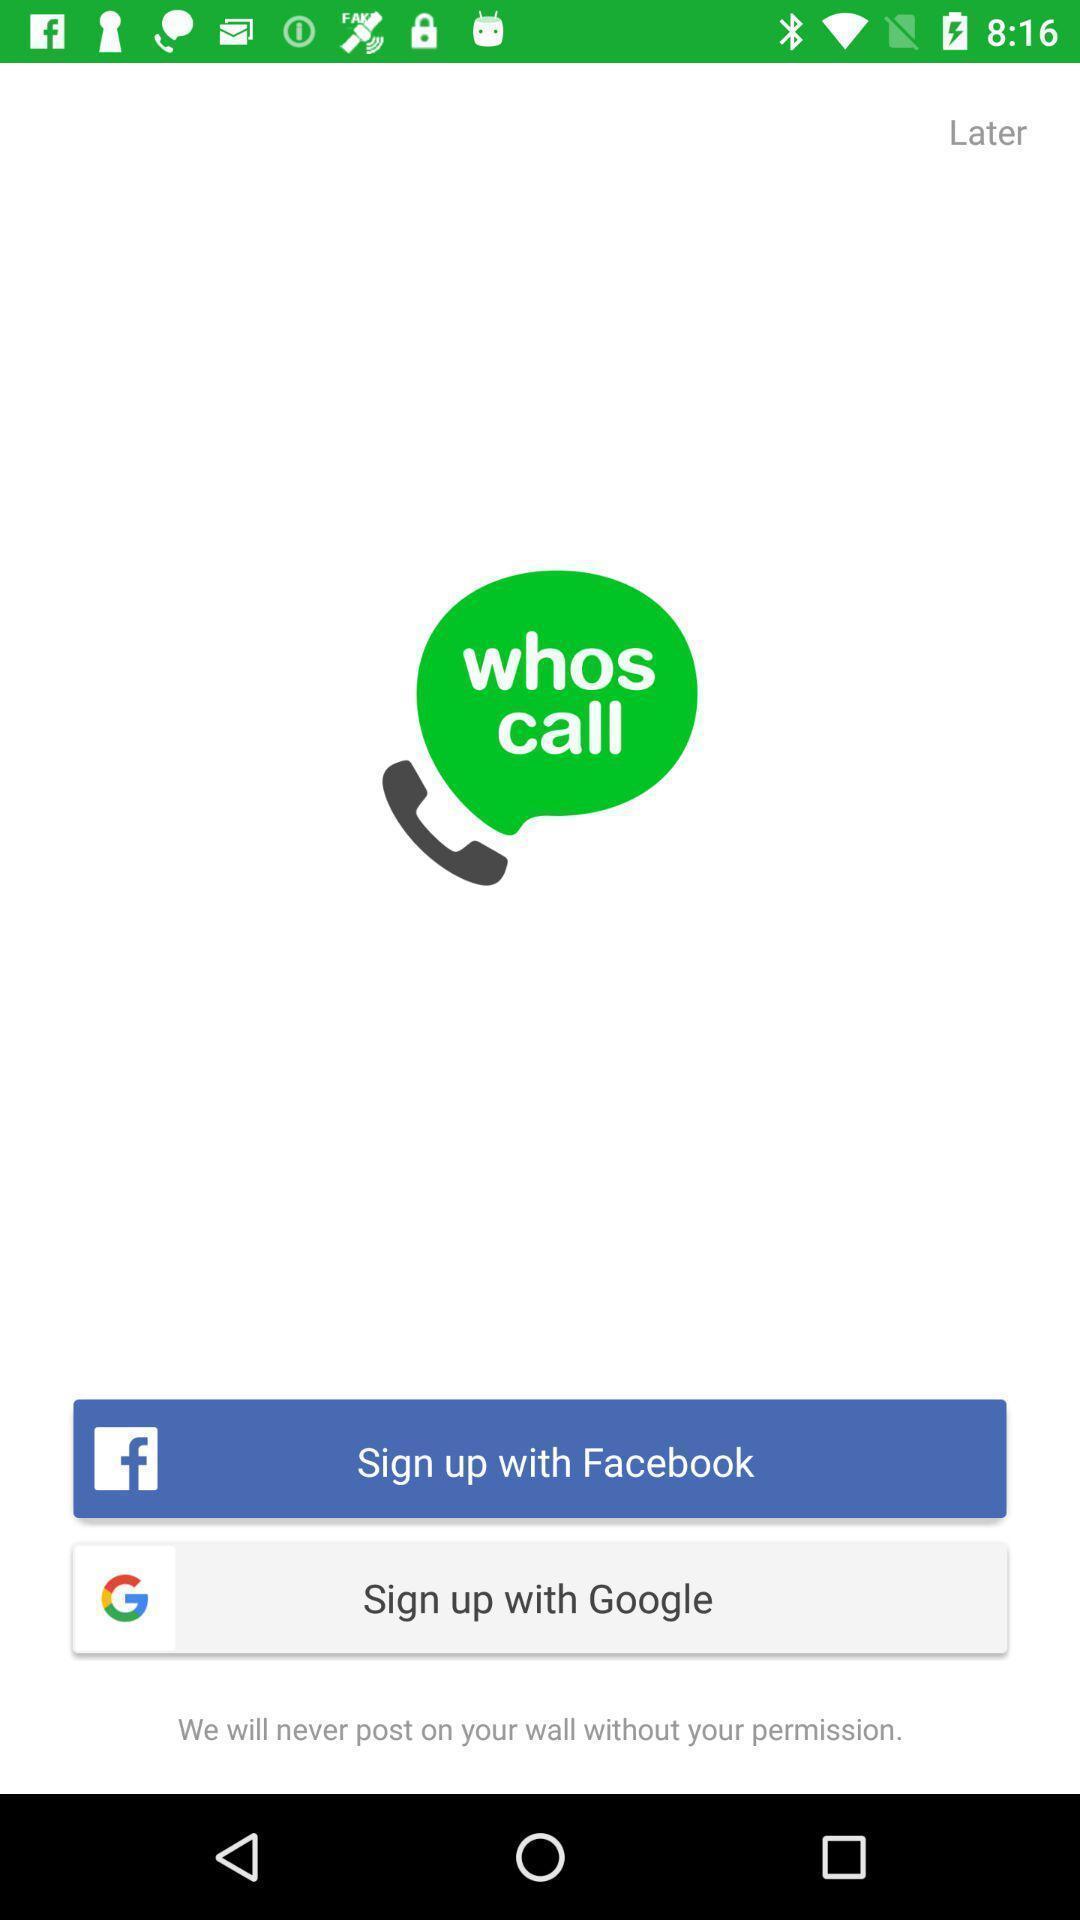Tell me about the visual elements in this screen capture. Sign-up page with different social apps displayed. 